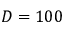<formula> <loc_0><loc_0><loc_500><loc_500>D = 1 0 0</formula> 